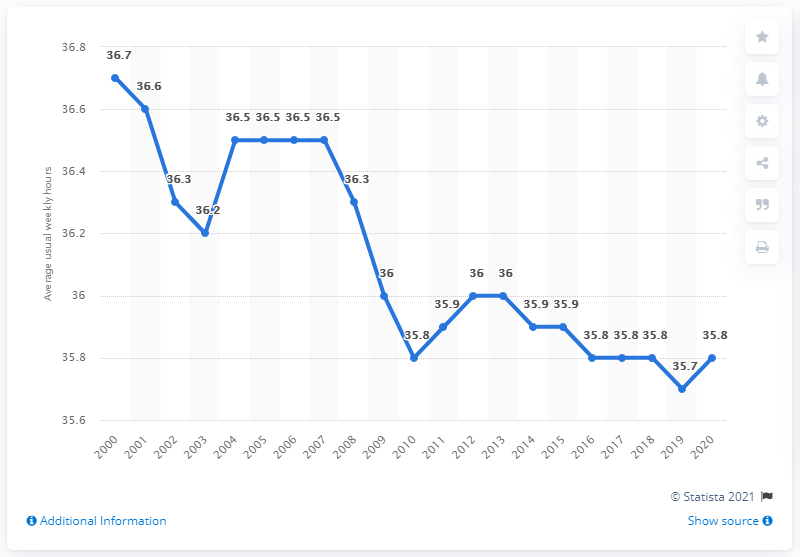Give some essential details in this illustration. The average usual weekly hours worked is equal to 36.5 for 4 years. In 2020, the average Canadian employee worked approximately 35.8 hours per week. In 2020, the average usual weekly hours worked at the main job in Canada was 35.8 hours per week. 